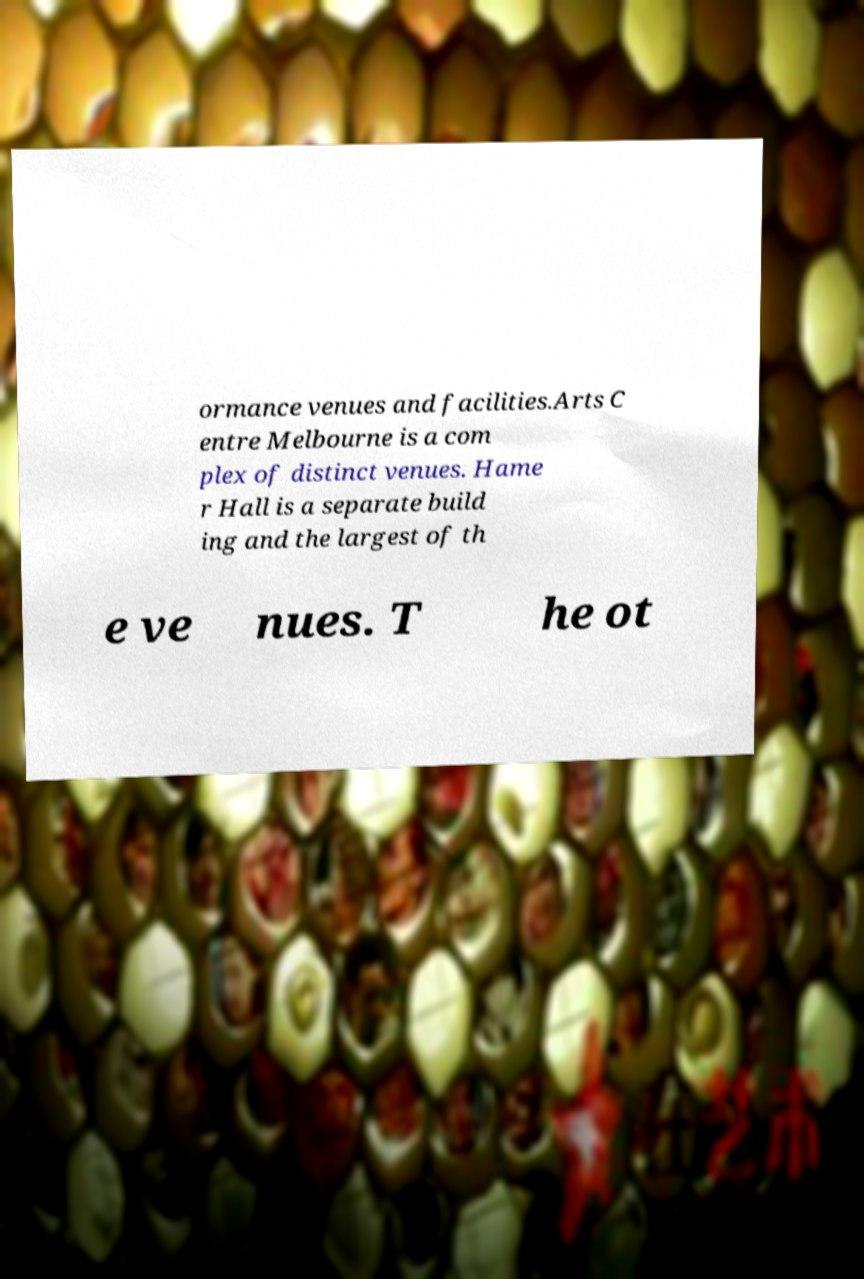Can you read and provide the text displayed in the image?This photo seems to have some interesting text. Can you extract and type it out for me? ormance venues and facilities.Arts C entre Melbourne is a com plex of distinct venues. Hame r Hall is a separate build ing and the largest of th e ve nues. T he ot 